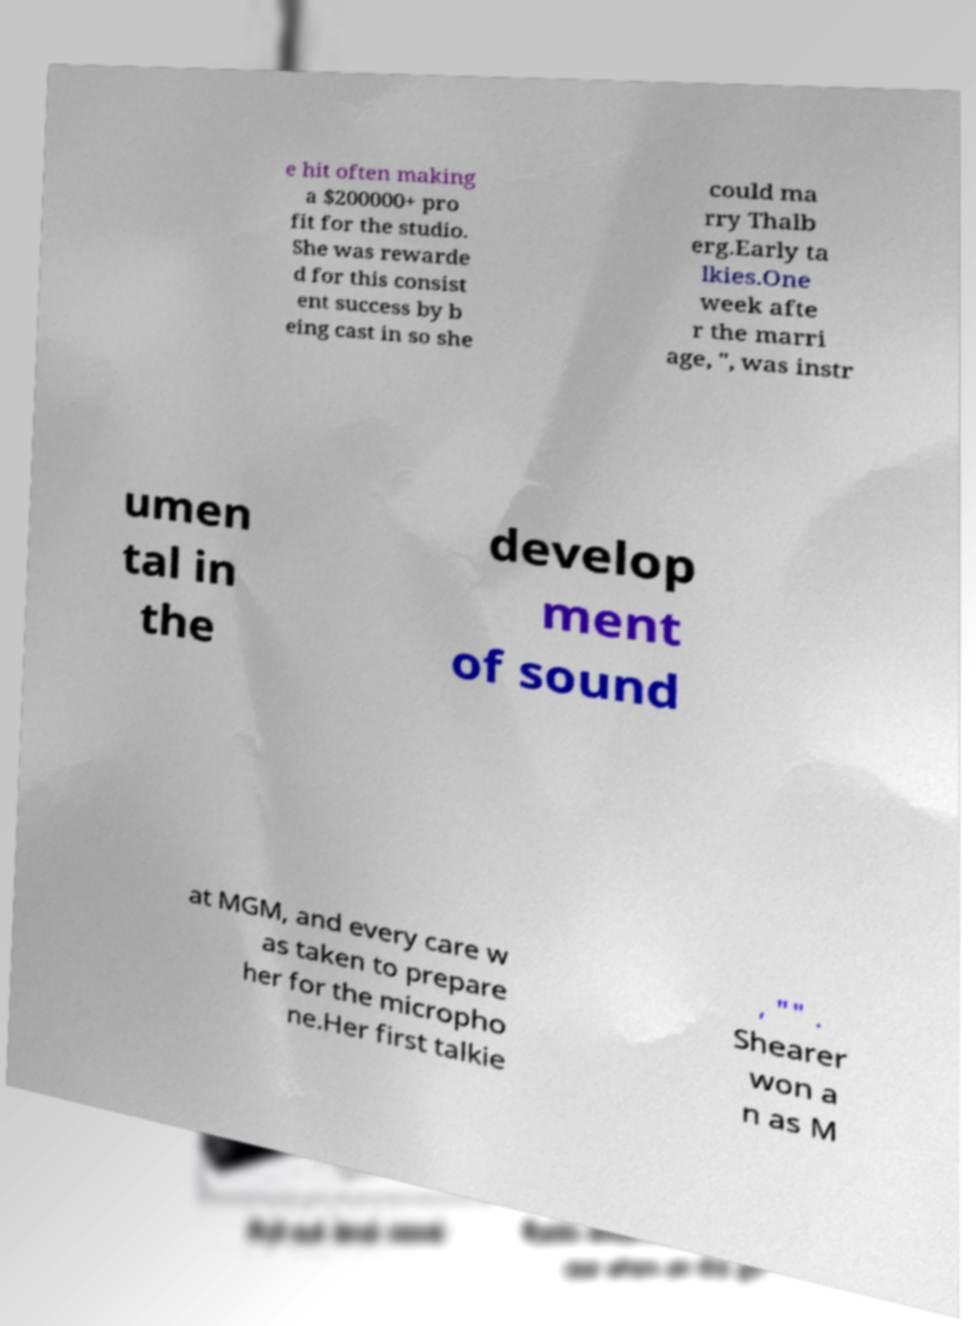Could you extract and type out the text from this image? e hit often making a $200000+ pro fit for the studio. She was rewarde d for this consist ent success by b eing cast in so she could ma rry Thalb erg.Early ta lkies.One week afte r the marri age, ", was instr umen tal in the develop ment of sound at MGM, and every care w as taken to prepare her for the micropho ne.Her first talkie , "" . Shearer won a n as M 